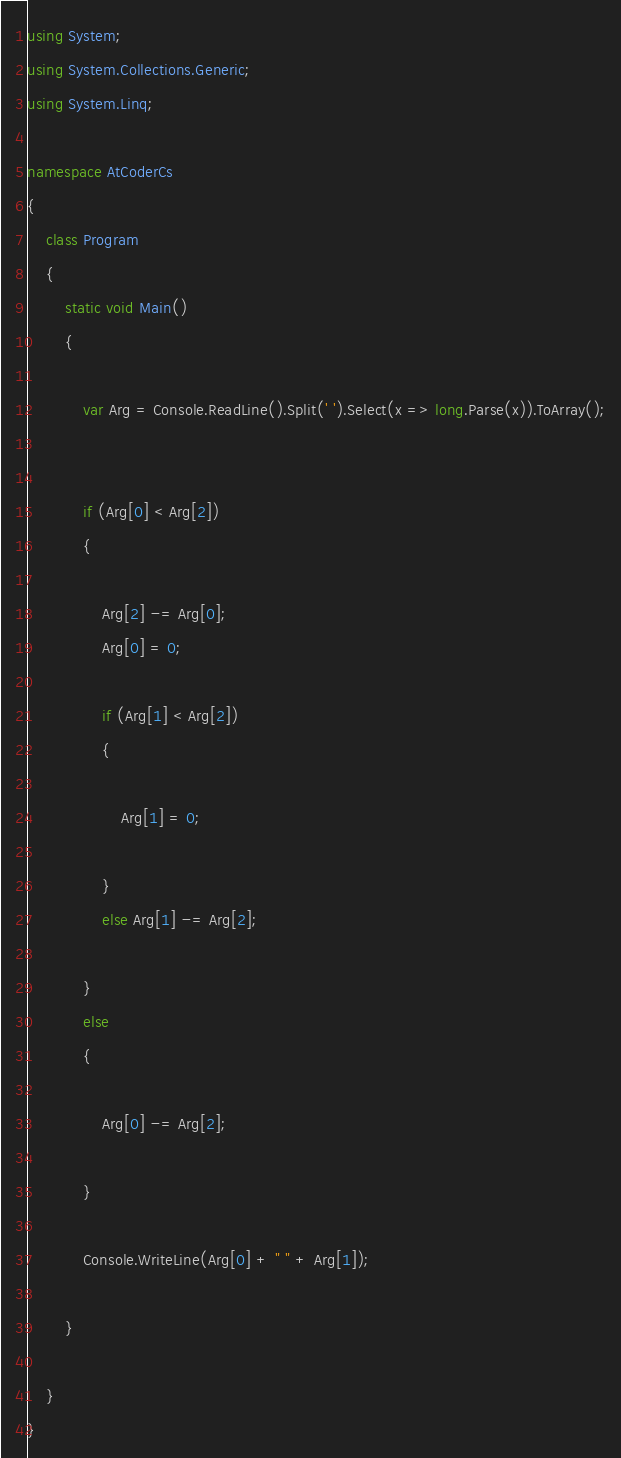<code> <loc_0><loc_0><loc_500><loc_500><_C#_>using System;
using System.Collections.Generic;
using System.Linq;

namespace AtCoderCs
{
    class Program
    {
        static void Main()
        {

            var Arg = Console.ReadLine().Split(' ').Select(x => long.Parse(x)).ToArray();


            if (Arg[0] < Arg[2])
            {

                Arg[2] -= Arg[0];
                Arg[0] = 0;

                if (Arg[1] < Arg[2])
                {

                    Arg[1] = 0;

                }
                else Arg[1] -= Arg[2];

            }
            else
            {

                Arg[0] -= Arg[2];

            }

            Console.WriteLine(Arg[0] + " " + Arg[1]);

        }

    }
}
</code> 